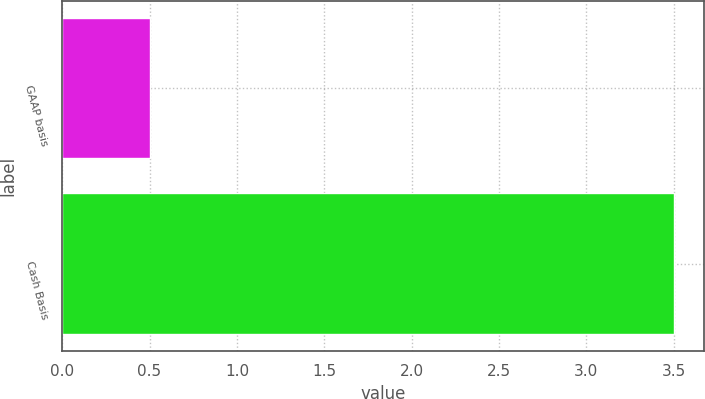<chart> <loc_0><loc_0><loc_500><loc_500><bar_chart><fcel>GAAP basis<fcel>Cash Basis<nl><fcel>0.5<fcel>3.5<nl></chart> 